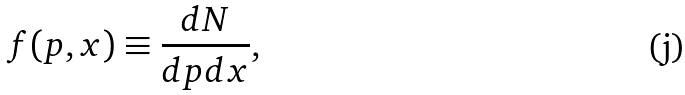<formula> <loc_0><loc_0><loc_500><loc_500>f ( { p } , { x } ) \equiv \frac { d N } { d { p } d { x } } ,</formula> 